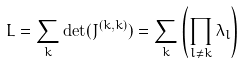Convert formula to latex. <formula><loc_0><loc_0><loc_500><loc_500>L = \sum _ { k } \det ( J ^ { ( k , k ) } ) = \sum _ { k } \left ( \prod _ { l \neq k } \lambda _ { l } \right )</formula> 